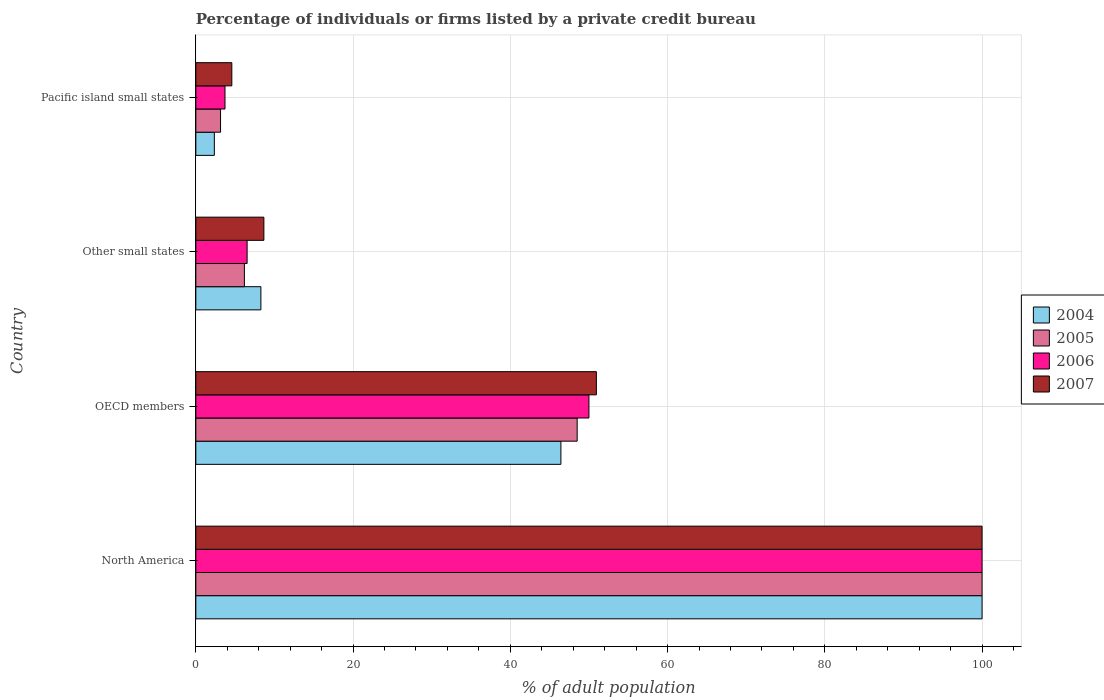How many different coloured bars are there?
Provide a short and direct response. 4. How many groups of bars are there?
Your answer should be compact. 4. Are the number of bars on each tick of the Y-axis equal?
Offer a terse response. Yes. How many bars are there on the 3rd tick from the top?
Your answer should be very brief. 4. How many bars are there on the 3rd tick from the bottom?
Provide a short and direct response. 4. What is the label of the 4th group of bars from the top?
Make the answer very short. North America. In how many cases, is the number of bars for a given country not equal to the number of legend labels?
Make the answer very short. 0. What is the percentage of population listed by a private credit bureau in 2005 in Other small states?
Ensure brevity in your answer.  6.18. Across all countries, what is the maximum percentage of population listed by a private credit bureau in 2005?
Make the answer very short. 100. Across all countries, what is the minimum percentage of population listed by a private credit bureau in 2004?
Your response must be concise. 2.36. In which country was the percentage of population listed by a private credit bureau in 2004 minimum?
Provide a short and direct response. Pacific island small states. What is the total percentage of population listed by a private credit bureau in 2005 in the graph?
Your answer should be compact. 157.82. What is the difference between the percentage of population listed by a private credit bureau in 2007 in Other small states and that in Pacific island small states?
Keep it short and to the point. 4.08. What is the average percentage of population listed by a private credit bureau in 2005 per country?
Keep it short and to the point. 39.46. What is the difference between the percentage of population listed by a private credit bureau in 2007 and percentage of population listed by a private credit bureau in 2005 in OECD members?
Offer a terse response. 2.44. What is the ratio of the percentage of population listed by a private credit bureau in 2004 in North America to that in Other small states?
Provide a short and direct response. 12.08. Is the percentage of population listed by a private credit bureau in 2006 in OECD members less than that in Other small states?
Ensure brevity in your answer.  No. Is the difference between the percentage of population listed by a private credit bureau in 2007 in Other small states and Pacific island small states greater than the difference between the percentage of population listed by a private credit bureau in 2005 in Other small states and Pacific island small states?
Offer a terse response. Yes. What is the difference between the highest and the second highest percentage of population listed by a private credit bureau in 2004?
Your response must be concise. 53.57. What is the difference between the highest and the lowest percentage of population listed by a private credit bureau in 2004?
Offer a terse response. 97.64. In how many countries, is the percentage of population listed by a private credit bureau in 2004 greater than the average percentage of population listed by a private credit bureau in 2004 taken over all countries?
Provide a succinct answer. 2. Is it the case that in every country, the sum of the percentage of population listed by a private credit bureau in 2005 and percentage of population listed by a private credit bureau in 2007 is greater than the sum of percentage of population listed by a private credit bureau in 2004 and percentage of population listed by a private credit bureau in 2006?
Your answer should be compact. No. What does the 2nd bar from the top in Pacific island small states represents?
Ensure brevity in your answer.  2006. Is it the case that in every country, the sum of the percentage of population listed by a private credit bureau in 2007 and percentage of population listed by a private credit bureau in 2006 is greater than the percentage of population listed by a private credit bureau in 2005?
Make the answer very short. Yes. How many bars are there?
Keep it short and to the point. 16. Are all the bars in the graph horizontal?
Ensure brevity in your answer.  Yes. Does the graph contain grids?
Provide a short and direct response. Yes. Where does the legend appear in the graph?
Keep it short and to the point. Center right. How many legend labels are there?
Give a very brief answer. 4. What is the title of the graph?
Ensure brevity in your answer.  Percentage of individuals or firms listed by a private credit bureau. Does "2006" appear as one of the legend labels in the graph?
Your response must be concise. Yes. What is the label or title of the X-axis?
Your answer should be compact. % of adult population. What is the % of adult population in 2004 in North America?
Keep it short and to the point. 100. What is the % of adult population of 2005 in North America?
Ensure brevity in your answer.  100. What is the % of adult population in 2006 in North America?
Provide a short and direct response. 100. What is the % of adult population in 2007 in North America?
Keep it short and to the point. 100. What is the % of adult population in 2004 in OECD members?
Ensure brevity in your answer.  46.43. What is the % of adult population of 2005 in OECD members?
Provide a short and direct response. 48.5. What is the % of adult population of 2007 in OECD members?
Your response must be concise. 50.95. What is the % of adult population of 2004 in Other small states?
Offer a very short reply. 8.28. What is the % of adult population in 2005 in Other small states?
Give a very brief answer. 6.18. What is the % of adult population of 2006 in Other small states?
Provide a short and direct response. 6.52. What is the % of adult population in 2007 in Other small states?
Offer a terse response. 8.66. What is the % of adult population in 2004 in Pacific island small states?
Ensure brevity in your answer.  2.36. What is the % of adult population of 2005 in Pacific island small states?
Make the answer very short. 3.14. What is the % of adult population in 2006 in Pacific island small states?
Keep it short and to the point. 3.71. What is the % of adult population in 2007 in Pacific island small states?
Your response must be concise. 4.58. Across all countries, what is the minimum % of adult population of 2004?
Provide a short and direct response. 2.36. Across all countries, what is the minimum % of adult population of 2005?
Give a very brief answer. 3.14. Across all countries, what is the minimum % of adult population of 2006?
Ensure brevity in your answer.  3.71. Across all countries, what is the minimum % of adult population of 2007?
Ensure brevity in your answer.  4.58. What is the total % of adult population in 2004 in the graph?
Offer a very short reply. 157.06. What is the total % of adult population of 2005 in the graph?
Keep it short and to the point. 157.82. What is the total % of adult population of 2006 in the graph?
Keep it short and to the point. 160.23. What is the total % of adult population of 2007 in the graph?
Provide a short and direct response. 164.18. What is the difference between the % of adult population in 2004 in North America and that in OECD members?
Your response must be concise. 53.57. What is the difference between the % of adult population in 2005 in North America and that in OECD members?
Keep it short and to the point. 51.5. What is the difference between the % of adult population in 2007 in North America and that in OECD members?
Make the answer very short. 49.05. What is the difference between the % of adult population of 2004 in North America and that in Other small states?
Keep it short and to the point. 91.72. What is the difference between the % of adult population in 2005 in North America and that in Other small states?
Make the answer very short. 93.82. What is the difference between the % of adult population of 2006 in North America and that in Other small states?
Ensure brevity in your answer.  93.48. What is the difference between the % of adult population in 2007 in North America and that in Other small states?
Your answer should be compact. 91.34. What is the difference between the % of adult population in 2004 in North America and that in Pacific island small states?
Make the answer very short. 97.64. What is the difference between the % of adult population in 2005 in North America and that in Pacific island small states?
Offer a terse response. 96.86. What is the difference between the % of adult population in 2006 in North America and that in Pacific island small states?
Your answer should be very brief. 96.29. What is the difference between the % of adult population in 2007 in North America and that in Pacific island small states?
Give a very brief answer. 95.42. What is the difference between the % of adult population of 2004 in OECD members and that in Other small states?
Your answer should be very brief. 38.16. What is the difference between the % of adult population of 2005 in OECD members and that in Other small states?
Make the answer very short. 42.33. What is the difference between the % of adult population in 2006 in OECD members and that in Other small states?
Keep it short and to the point. 43.48. What is the difference between the % of adult population of 2007 in OECD members and that in Other small states?
Make the answer very short. 42.29. What is the difference between the % of adult population in 2004 in OECD members and that in Pacific island small states?
Offer a terse response. 44.08. What is the difference between the % of adult population in 2005 in OECD members and that in Pacific island small states?
Make the answer very short. 45.36. What is the difference between the % of adult population in 2006 in OECD members and that in Pacific island small states?
Provide a short and direct response. 46.29. What is the difference between the % of adult population in 2007 in OECD members and that in Pacific island small states?
Make the answer very short. 46.37. What is the difference between the % of adult population in 2004 in Other small states and that in Pacific island small states?
Your answer should be very brief. 5.92. What is the difference between the % of adult population of 2005 in Other small states and that in Pacific island small states?
Keep it short and to the point. 3.03. What is the difference between the % of adult population of 2006 in Other small states and that in Pacific island small states?
Keep it short and to the point. 2.81. What is the difference between the % of adult population of 2007 in Other small states and that in Pacific island small states?
Give a very brief answer. 4.08. What is the difference between the % of adult population in 2004 in North America and the % of adult population in 2005 in OECD members?
Provide a succinct answer. 51.5. What is the difference between the % of adult population in 2004 in North America and the % of adult population in 2006 in OECD members?
Provide a succinct answer. 50. What is the difference between the % of adult population in 2004 in North America and the % of adult population in 2007 in OECD members?
Your answer should be very brief. 49.05. What is the difference between the % of adult population of 2005 in North America and the % of adult population of 2007 in OECD members?
Provide a succinct answer. 49.05. What is the difference between the % of adult population of 2006 in North America and the % of adult population of 2007 in OECD members?
Ensure brevity in your answer.  49.05. What is the difference between the % of adult population in 2004 in North America and the % of adult population in 2005 in Other small states?
Offer a very short reply. 93.82. What is the difference between the % of adult population in 2004 in North America and the % of adult population in 2006 in Other small states?
Ensure brevity in your answer.  93.48. What is the difference between the % of adult population in 2004 in North America and the % of adult population in 2007 in Other small states?
Provide a short and direct response. 91.34. What is the difference between the % of adult population in 2005 in North America and the % of adult population in 2006 in Other small states?
Ensure brevity in your answer.  93.48. What is the difference between the % of adult population in 2005 in North America and the % of adult population in 2007 in Other small states?
Provide a succinct answer. 91.34. What is the difference between the % of adult population in 2006 in North America and the % of adult population in 2007 in Other small states?
Ensure brevity in your answer.  91.34. What is the difference between the % of adult population of 2004 in North America and the % of adult population of 2005 in Pacific island small states?
Keep it short and to the point. 96.86. What is the difference between the % of adult population of 2004 in North America and the % of adult population of 2006 in Pacific island small states?
Your response must be concise. 96.29. What is the difference between the % of adult population in 2004 in North America and the % of adult population in 2007 in Pacific island small states?
Your answer should be very brief. 95.42. What is the difference between the % of adult population in 2005 in North America and the % of adult population in 2006 in Pacific island small states?
Provide a succinct answer. 96.29. What is the difference between the % of adult population of 2005 in North America and the % of adult population of 2007 in Pacific island small states?
Give a very brief answer. 95.42. What is the difference between the % of adult population of 2006 in North America and the % of adult population of 2007 in Pacific island small states?
Keep it short and to the point. 95.42. What is the difference between the % of adult population of 2004 in OECD members and the % of adult population of 2005 in Other small states?
Keep it short and to the point. 40.26. What is the difference between the % of adult population in 2004 in OECD members and the % of adult population in 2006 in Other small states?
Your answer should be very brief. 39.91. What is the difference between the % of adult population of 2004 in OECD members and the % of adult population of 2007 in Other small states?
Provide a short and direct response. 37.78. What is the difference between the % of adult population of 2005 in OECD members and the % of adult population of 2006 in Other small states?
Give a very brief answer. 41.98. What is the difference between the % of adult population of 2005 in OECD members and the % of adult population of 2007 in Other small states?
Ensure brevity in your answer.  39.85. What is the difference between the % of adult population of 2006 in OECD members and the % of adult population of 2007 in Other small states?
Your answer should be compact. 41.34. What is the difference between the % of adult population in 2004 in OECD members and the % of adult population in 2005 in Pacific island small states?
Your answer should be compact. 43.29. What is the difference between the % of adult population of 2004 in OECD members and the % of adult population of 2006 in Pacific island small states?
Make the answer very short. 42.72. What is the difference between the % of adult population in 2004 in OECD members and the % of adult population in 2007 in Pacific island small states?
Offer a terse response. 41.86. What is the difference between the % of adult population in 2005 in OECD members and the % of adult population in 2006 in Pacific island small states?
Provide a succinct answer. 44.79. What is the difference between the % of adult population in 2005 in OECD members and the % of adult population in 2007 in Pacific island small states?
Your answer should be very brief. 43.93. What is the difference between the % of adult population of 2006 in OECD members and the % of adult population of 2007 in Pacific island small states?
Your response must be concise. 45.42. What is the difference between the % of adult population of 2004 in Other small states and the % of adult population of 2005 in Pacific island small states?
Keep it short and to the point. 5.13. What is the difference between the % of adult population in 2004 in Other small states and the % of adult population in 2006 in Pacific island small states?
Offer a terse response. 4.56. What is the difference between the % of adult population in 2004 in Other small states and the % of adult population in 2007 in Pacific island small states?
Provide a succinct answer. 3.7. What is the difference between the % of adult population of 2005 in Other small states and the % of adult population of 2006 in Pacific island small states?
Make the answer very short. 2.47. What is the difference between the % of adult population of 2005 in Other small states and the % of adult population of 2007 in Pacific island small states?
Offer a terse response. 1.6. What is the difference between the % of adult population in 2006 in Other small states and the % of adult population in 2007 in Pacific island small states?
Make the answer very short. 1.94. What is the average % of adult population of 2004 per country?
Your response must be concise. 39.27. What is the average % of adult population in 2005 per country?
Give a very brief answer. 39.46. What is the average % of adult population in 2006 per country?
Keep it short and to the point. 40.06. What is the average % of adult population of 2007 per country?
Offer a very short reply. 41.04. What is the difference between the % of adult population in 2004 and % of adult population in 2006 in North America?
Ensure brevity in your answer.  0. What is the difference between the % of adult population of 2005 and % of adult population of 2007 in North America?
Provide a short and direct response. 0. What is the difference between the % of adult population in 2004 and % of adult population in 2005 in OECD members?
Offer a terse response. -2.07. What is the difference between the % of adult population in 2004 and % of adult population in 2006 in OECD members?
Your response must be concise. -3.57. What is the difference between the % of adult population of 2004 and % of adult population of 2007 in OECD members?
Your answer should be very brief. -4.51. What is the difference between the % of adult population in 2005 and % of adult population in 2006 in OECD members?
Your response must be concise. -1.5. What is the difference between the % of adult population in 2005 and % of adult population in 2007 in OECD members?
Your answer should be very brief. -2.44. What is the difference between the % of adult population in 2006 and % of adult population in 2007 in OECD members?
Your answer should be compact. -0.95. What is the difference between the % of adult population in 2004 and % of adult population in 2005 in Other small states?
Make the answer very short. 2.1. What is the difference between the % of adult population of 2004 and % of adult population of 2006 in Other small states?
Ensure brevity in your answer.  1.75. What is the difference between the % of adult population in 2004 and % of adult population in 2007 in Other small states?
Provide a succinct answer. -0.38. What is the difference between the % of adult population in 2005 and % of adult population in 2006 in Other small states?
Your response must be concise. -0.35. What is the difference between the % of adult population of 2005 and % of adult population of 2007 in Other small states?
Keep it short and to the point. -2.48. What is the difference between the % of adult population of 2006 and % of adult population of 2007 in Other small states?
Your answer should be compact. -2.13. What is the difference between the % of adult population in 2004 and % of adult population in 2005 in Pacific island small states?
Your answer should be very brief. -0.79. What is the difference between the % of adult population in 2004 and % of adult population in 2006 in Pacific island small states?
Your answer should be very brief. -1.36. What is the difference between the % of adult population of 2004 and % of adult population of 2007 in Pacific island small states?
Your answer should be very brief. -2.22. What is the difference between the % of adult population of 2005 and % of adult population of 2006 in Pacific island small states?
Make the answer very short. -0.57. What is the difference between the % of adult population of 2005 and % of adult population of 2007 in Pacific island small states?
Ensure brevity in your answer.  -1.43. What is the difference between the % of adult population of 2006 and % of adult population of 2007 in Pacific island small states?
Give a very brief answer. -0.87. What is the ratio of the % of adult population of 2004 in North America to that in OECD members?
Give a very brief answer. 2.15. What is the ratio of the % of adult population of 2005 in North America to that in OECD members?
Your answer should be compact. 2.06. What is the ratio of the % of adult population in 2006 in North America to that in OECD members?
Your answer should be very brief. 2. What is the ratio of the % of adult population in 2007 in North America to that in OECD members?
Give a very brief answer. 1.96. What is the ratio of the % of adult population of 2004 in North America to that in Other small states?
Provide a succinct answer. 12.08. What is the ratio of the % of adult population of 2005 in North America to that in Other small states?
Your answer should be compact. 16.19. What is the ratio of the % of adult population of 2006 in North America to that in Other small states?
Your response must be concise. 15.33. What is the ratio of the % of adult population in 2007 in North America to that in Other small states?
Offer a terse response. 11.55. What is the ratio of the % of adult population of 2004 in North America to that in Pacific island small states?
Keep it short and to the point. 42.45. What is the ratio of the % of adult population in 2005 in North America to that in Pacific island small states?
Give a very brief answer. 31.8. What is the ratio of the % of adult population in 2006 in North America to that in Pacific island small states?
Your answer should be compact. 26.95. What is the ratio of the % of adult population in 2007 in North America to that in Pacific island small states?
Make the answer very short. 21.84. What is the ratio of the % of adult population of 2004 in OECD members to that in Other small states?
Provide a short and direct response. 5.61. What is the ratio of the % of adult population in 2005 in OECD members to that in Other small states?
Offer a very short reply. 7.85. What is the ratio of the % of adult population of 2006 in OECD members to that in Other small states?
Your response must be concise. 7.67. What is the ratio of the % of adult population of 2007 in OECD members to that in Other small states?
Offer a very short reply. 5.89. What is the ratio of the % of adult population in 2004 in OECD members to that in Pacific island small states?
Offer a terse response. 19.71. What is the ratio of the % of adult population of 2005 in OECD members to that in Pacific island small states?
Keep it short and to the point. 15.43. What is the ratio of the % of adult population in 2006 in OECD members to that in Pacific island small states?
Provide a succinct answer. 13.47. What is the ratio of the % of adult population in 2007 in OECD members to that in Pacific island small states?
Ensure brevity in your answer.  11.13. What is the ratio of the % of adult population in 2004 in Other small states to that in Pacific island small states?
Provide a short and direct response. 3.51. What is the ratio of the % of adult population of 2005 in Other small states to that in Pacific island small states?
Ensure brevity in your answer.  1.96. What is the ratio of the % of adult population of 2006 in Other small states to that in Pacific island small states?
Provide a succinct answer. 1.76. What is the ratio of the % of adult population of 2007 in Other small states to that in Pacific island small states?
Keep it short and to the point. 1.89. What is the difference between the highest and the second highest % of adult population of 2004?
Provide a short and direct response. 53.57. What is the difference between the highest and the second highest % of adult population of 2005?
Give a very brief answer. 51.5. What is the difference between the highest and the second highest % of adult population of 2007?
Give a very brief answer. 49.05. What is the difference between the highest and the lowest % of adult population in 2004?
Offer a terse response. 97.64. What is the difference between the highest and the lowest % of adult population in 2005?
Offer a terse response. 96.86. What is the difference between the highest and the lowest % of adult population in 2006?
Give a very brief answer. 96.29. What is the difference between the highest and the lowest % of adult population in 2007?
Offer a terse response. 95.42. 